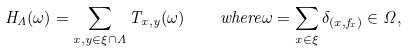Convert formula to latex. <formula><loc_0><loc_0><loc_500><loc_500>H _ { \Lambda } ( \omega ) = \sum _ { x , y \in \xi \cap \Lambda } T _ { x , y } ( \omega ) \quad w h e r e \omega = \sum _ { x \in \xi } \delta _ { ( x , f _ { x } ) } \in \Omega ,</formula> 